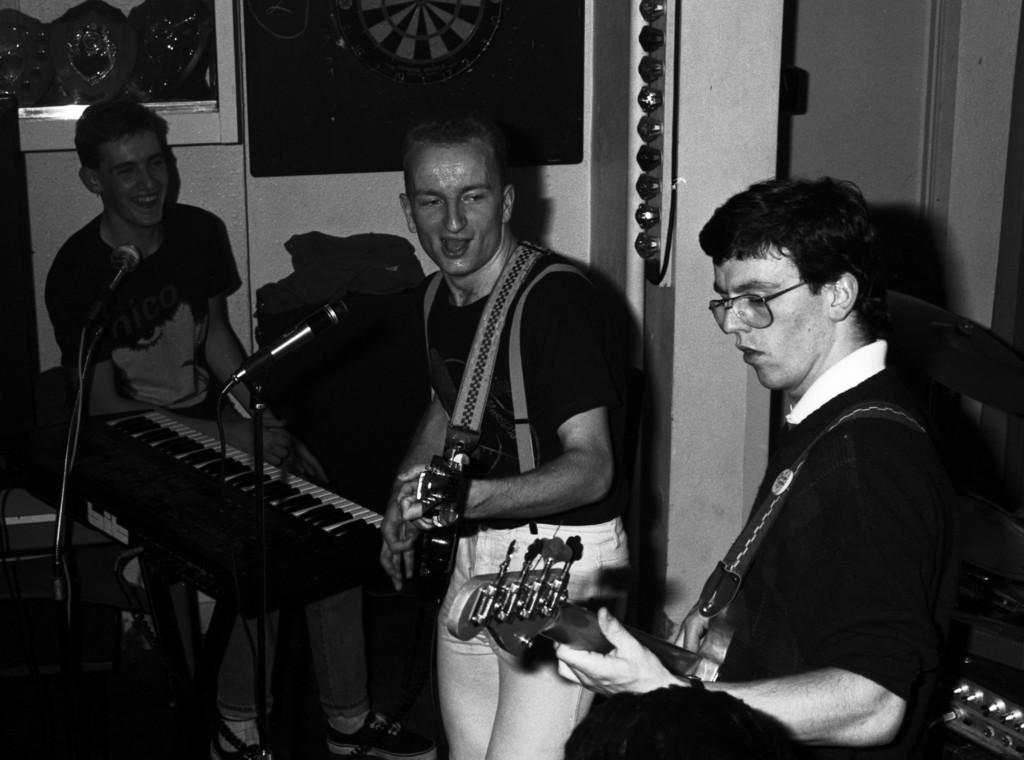What are the people in the image doing? The persons in the image are playing musical instruments. What objects are present at the foreground of the image? There are microphones at the foreground of the image. How many eyes can be seen on the pest in the image? There is no pest present in the image, so the number of eyes cannot be determined. 